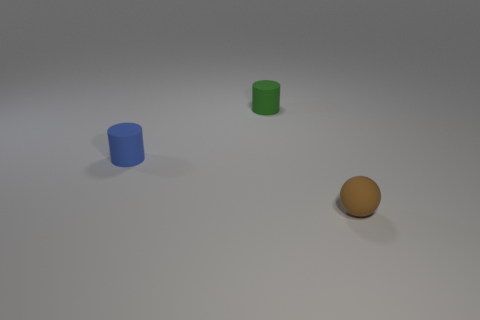Add 3 blocks. How many objects exist? 6 Subtract all cylinders. How many objects are left? 1 Add 2 big green rubber balls. How many big green rubber balls exist? 2 Subtract 0 cyan blocks. How many objects are left? 3 Subtract all blue spheres. Subtract all purple cylinders. How many spheres are left? 1 Subtract all spheres. Subtract all small gray metallic cylinders. How many objects are left? 2 Add 1 matte cylinders. How many matte cylinders are left? 3 